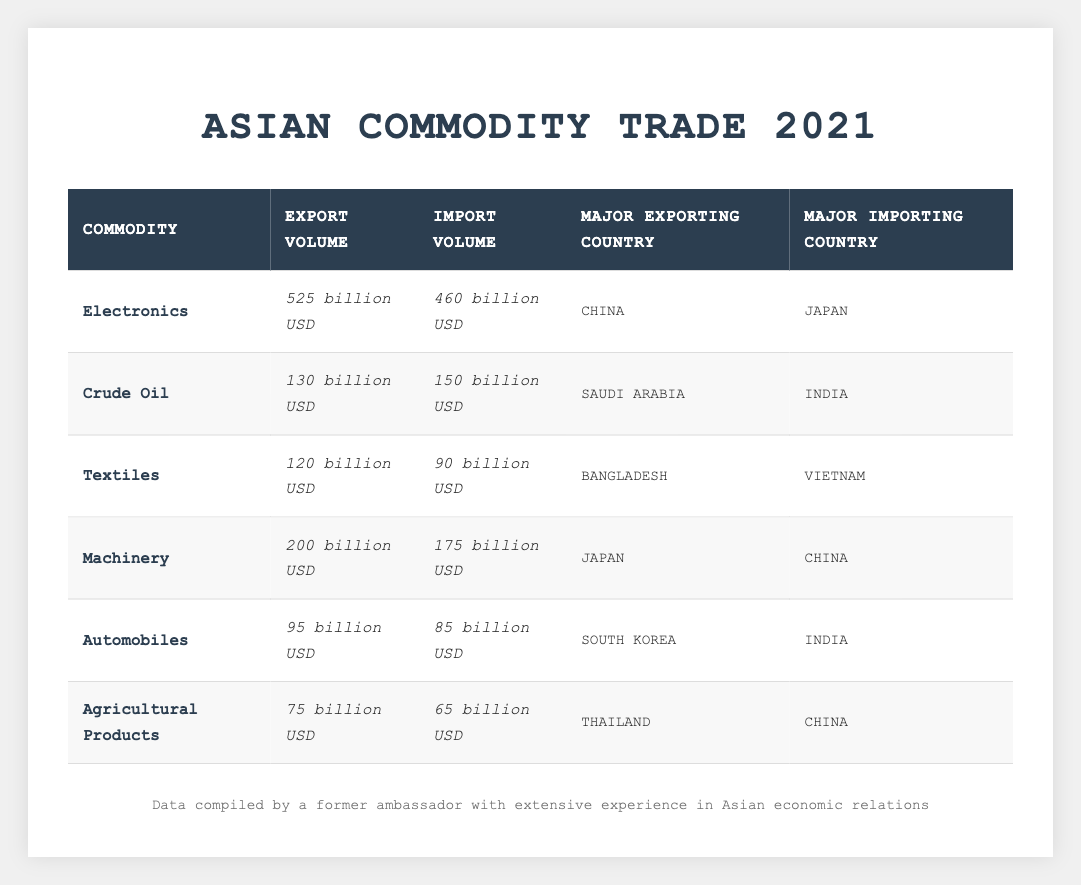What is the export volume of Electronics? According to the table, the export volume for Electronics is listed as 525 billion USD.
Answer: 525 billion USD Who is the major exporting country for Textiles? The table indicates that Bangladesh is the major exporting country for Textiles.
Answer: Bangladesh Which commodity has the highest import volume? By reviewing the import volumes, Crude Oil has the highest import volume at 150 billion USD.
Answer: Crude Oil What was the import volume of Agricultural Products in 2021? The table specifies that the import volume for Agricultural Products was 65 billion USD.
Answer: 65 billion USD Calculate the total export volume of all commodities listed. Adding the export volumes: 525 (Electronics) + 130 (Crude Oil) + 120 (Textiles) + 200 (Machinery) + 95 (Automobiles) + 75 (Agricultural Products) = 1,145 billion USD.
Answer: 1,145 billion USD Is it true that South Korea is the major importing country for Automobiles? The table specifies that the major importing country for Automobiles is India, not South Korea, so the statement is false.
Answer: False What is the difference between the export volume and import volume of Machinery? The export volume for Machinery is 200 billion USD and the import volume is 175 billion USD. The difference is 200 - 175 = 25 billion USD.
Answer: 25 billion USD Which commodity has the lowest export volume? By comparing all the export volumes, Agricultural Products have the lowest export volume at 75 billion USD.
Answer: Agricultural Products If you combine the import volumes of Crude Oil and Textiles, what do you get? The import volumes for Crude Oil (150 billion USD) and Textiles (90 billion USD) add up to 240 billion USD (150 + 90 = 240).
Answer: 240 billion USD Who is the major importing country for Electronics? The table shows that Japan is the major importing country for Electronics.
Answer: Japan 